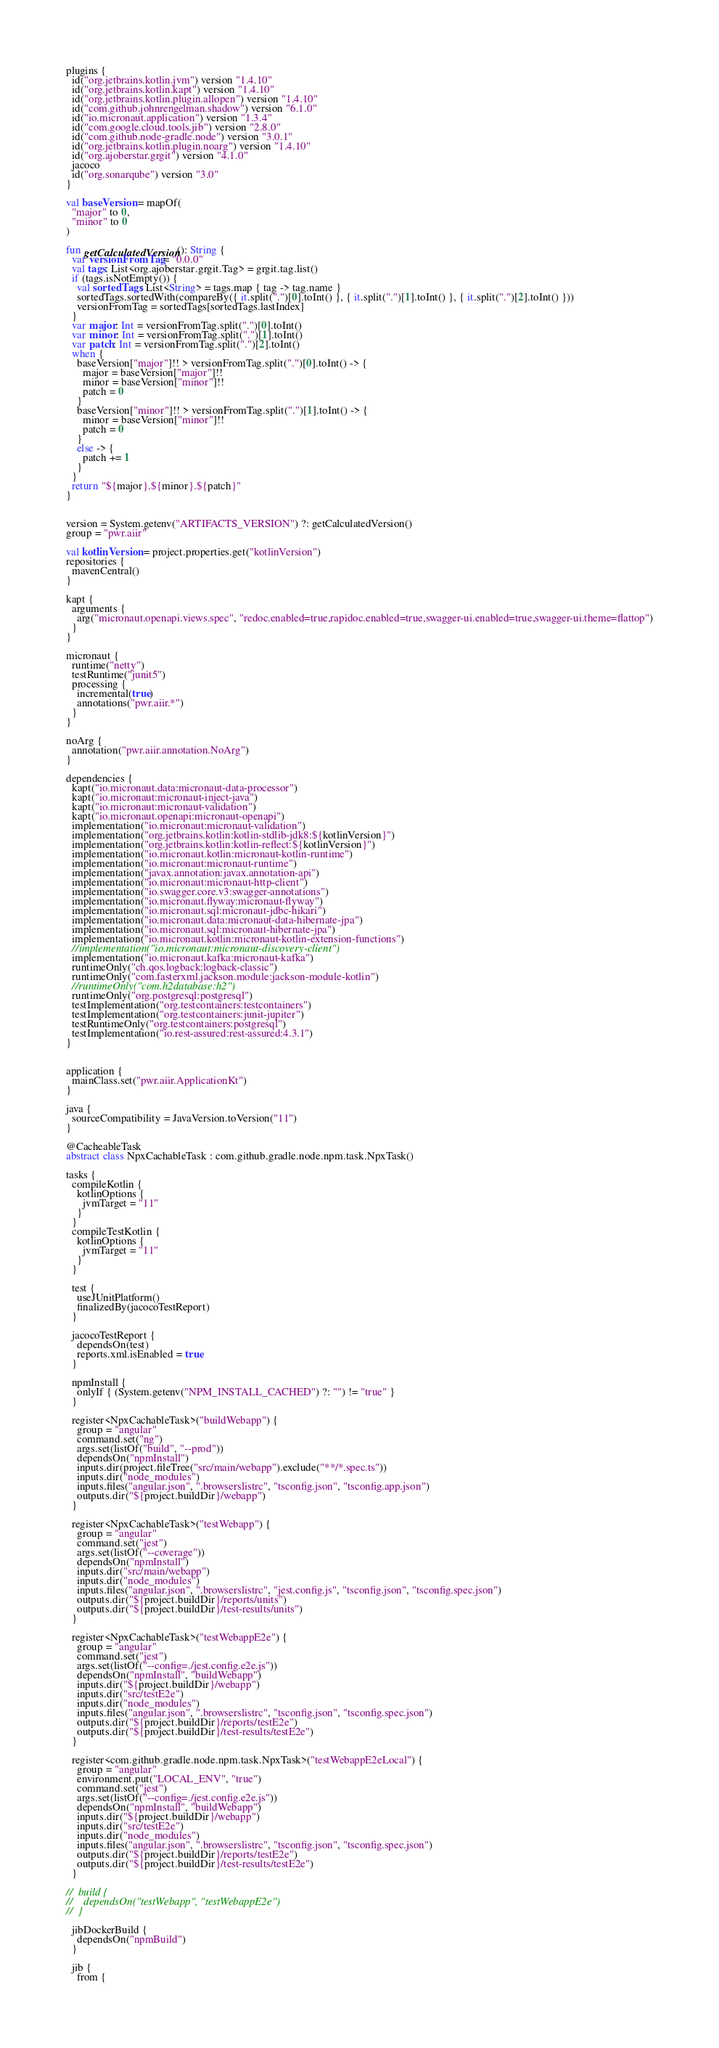Convert code to text. <code><loc_0><loc_0><loc_500><loc_500><_Kotlin_>plugins {
  id("org.jetbrains.kotlin.jvm") version "1.4.10"
  id("org.jetbrains.kotlin.kapt") version "1.4.10"
  id("org.jetbrains.kotlin.plugin.allopen") version "1.4.10"
  id("com.github.johnrengelman.shadow") version "6.1.0"
  id("io.micronaut.application") version "1.3.4"
  id("com.google.cloud.tools.jib") version "2.8.0"
  id("com.github.node-gradle.node") version "3.0.1"
  id("org.jetbrains.kotlin.plugin.noarg") version "1.4.10"
  id("org.ajoberstar.grgit") version "4.1.0"
  jacoco
  id("org.sonarqube") version "3.0"
}

val baseVersion = mapOf(
  "major" to 0,
  "minor" to 0
)

fun getCalculatedVersion(): String {
  var versionFromTag = "0.0.0"
  val tags: List<org.ajoberstar.grgit.Tag> = grgit.tag.list()
  if (tags.isNotEmpty()) {
    val sortedTags: List<String> = tags.map { tag -> tag.name }
    sortedTags.sortedWith(compareBy({ it.split(".")[0].toInt() }, { it.split(".")[1].toInt() }, { it.split(".")[2].toInt() }))
    versionFromTag = sortedTags[sortedTags.lastIndex]
  }
  var major: Int = versionFromTag.split(".")[0].toInt()
  var minor: Int = versionFromTag.split(".")[1].toInt()
  var patch: Int = versionFromTag.split(".")[2].toInt()
  when {
    baseVersion["major"]!! > versionFromTag.split(".")[0].toInt() -> {
      major = baseVersion["major"]!!
      minor = baseVersion["minor"]!!
      patch = 0
    }
    baseVersion["minor"]!! > versionFromTag.split(".")[1].toInt() -> {
      minor = baseVersion["minor"]!!
      patch = 0
    }
    else -> {
      patch += 1
    }
  }
  return "${major}.${minor}.${patch}"
}


version = System.getenv("ARTIFACTS_VERSION") ?: getCalculatedVersion()
group = "pwr.aiir"

val kotlinVersion = project.properties.get("kotlinVersion")
repositories {
  mavenCentral()
}

kapt {
  arguments {
    arg("micronaut.openapi.views.spec", "redoc.enabled=true,rapidoc.enabled=true,swagger-ui.enabled=true,swagger-ui.theme=flattop")
  }
}

micronaut {
  runtime("netty")
  testRuntime("junit5")
  processing {
    incremental(true)
    annotations("pwr.aiir.*")
  }
}

noArg {
  annotation("pwr.aiir.annotation.NoArg")
}

dependencies {
  kapt("io.micronaut.data:micronaut-data-processor")
  kapt("io.micronaut:micronaut-inject-java")
  kapt("io.micronaut:micronaut-validation")
  kapt("io.micronaut.openapi:micronaut-openapi")
  implementation("io.micronaut:micronaut-validation")
  implementation("org.jetbrains.kotlin:kotlin-stdlib-jdk8:${kotlinVersion}")
  implementation("org.jetbrains.kotlin:kotlin-reflect:${kotlinVersion}")
  implementation("io.micronaut.kotlin:micronaut-kotlin-runtime")
  implementation("io.micronaut:micronaut-runtime")
  implementation("javax.annotation:javax.annotation-api")
  implementation("io.micronaut:micronaut-http-client")
  implementation("io.swagger.core.v3:swagger-annotations")
  implementation("io.micronaut.flyway:micronaut-flyway")
  implementation("io.micronaut.sql:micronaut-jdbc-hikari")
  implementation("io.micronaut.data:micronaut-data-hibernate-jpa")
  implementation("io.micronaut.sql:micronaut-hibernate-jpa")
  implementation("io.micronaut.kotlin:micronaut-kotlin-extension-functions")
  //implementation("io.micronaut:micronaut-discovery-client")
  implementation("io.micronaut.kafka:micronaut-kafka")
  runtimeOnly("ch.qos.logback:logback-classic")
  runtimeOnly("com.fasterxml.jackson.module:jackson-module-kotlin")
  //runtimeOnly("com.h2database:h2")
  runtimeOnly("org.postgresql:postgresql")
  testImplementation("org.testcontainers:testcontainers")
  testImplementation("org.testcontainers:junit-jupiter")
  testRuntimeOnly("org.testcontainers:postgresql")
  testImplementation("io.rest-assured:rest-assured:4.3.1")
}


application {
  mainClass.set("pwr.aiir.ApplicationKt")
}

java {
  sourceCompatibility = JavaVersion.toVersion("11")
}

@CacheableTask
abstract class NpxCachableTask : com.github.gradle.node.npm.task.NpxTask()

tasks {
  compileKotlin {
    kotlinOptions {
      jvmTarget = "11"
    }
  }
  compileTestKotlin {
    kotlinOptions {
      jvmTarget = "11"
    }
  }

  test {
    useJUnitPlatform()
    finalizedBy(jacocoTestReport)
  }

  jacocoTestReport {
    dependsOn(test)
    reports.xml.isEnabled = true
  }

  npmInstall {
    onlyIf { (System.getenv("NPM_INSTALL_CACHED") ?: "") != "true" }
  }

  register<NpxCachableTask>("buildWebapp") {
    group = "angular"
    command.set("ng")
    args.set(listOf("build", "--prod"))
    dependsOn("npmInstall")
    inputs.dir(project.fileTree("src/main/webapp").exclude("**/*.spec.ts"))
    inputs.dir("node_modules")
    inputs.files("angular.json", ".browserslistrc", "tsconfig.json", "tsconfig.app.json")
    outputs.dir("${project.buildDir}/webapp")
  }

  register<NpxCachableTask>("testWebapp") {
    group = "angular"
    command.set("jest")
    args.set(listOf("--coverage"))
    dependsOn("npmInstall")
    inputs.dir("src/main/webapp")
    inputs.dir("node_modules")
    inputs.files("angular.json", ".browserslistrc", "jest.config.js", "tsconfig.json", "tsconfig.spec.json")
    outputs.dir("${project.buildDir}/reports/units")
    outputs.dir("${project.buildDir}/test-results/units")
  }

  register<NpxCachableTask>("testWebappE2e") {
    group = "angular"
    command.set("jest")
    args.set(listOf("--config=./jest.config.e2e.js"))
    dependsOn("npmInstall", "buildWebapp")
    inputs.dir("${project.buildDir}/webapp")
    inputs.dir("src/testE2e")
    inputs.dir("node_modules")
    inputs.files("angular.json", ".browserslistrc", "tsconfig.json", "tsconfig.spec.json")
    outputs.dir("${project.buildDir}/reports/testE2e")
    outputs.dir("${project.buildDir}/test-results/testE2e")
  }

  register<com.github.gradle.node.npm.task.NpxTask>("testWebappE2eLocal") {
    group = "angular"
    environment.put("LOCAL_ENV", "true")
    command.set("jest")
    args.set(listOf("--config=./jest.config.e2e.js"))
    dependsOn("npmInstall", "buildWebapp")
    inputs.dir("${project.buildDir}/webapp")
    inputs.dir("src/testE2e")
    inputs.dir("node_modules")
    inputs.files("angular.json", ".browserslistrc", "tsconfig.json", "tsconfig.spec.json")
    outputs.dir("${project.buildDir}/reports/testE2e")
    outputs.dir("${project.buildDir}/test-results/testE2e")
  }

//  build {
//    dependsOn("testWebapp", "testWebappE2e")
//  }

  jibDockerBuild {
    dependsOn("npmBuild")
  }

  jib {
    from {</code> 